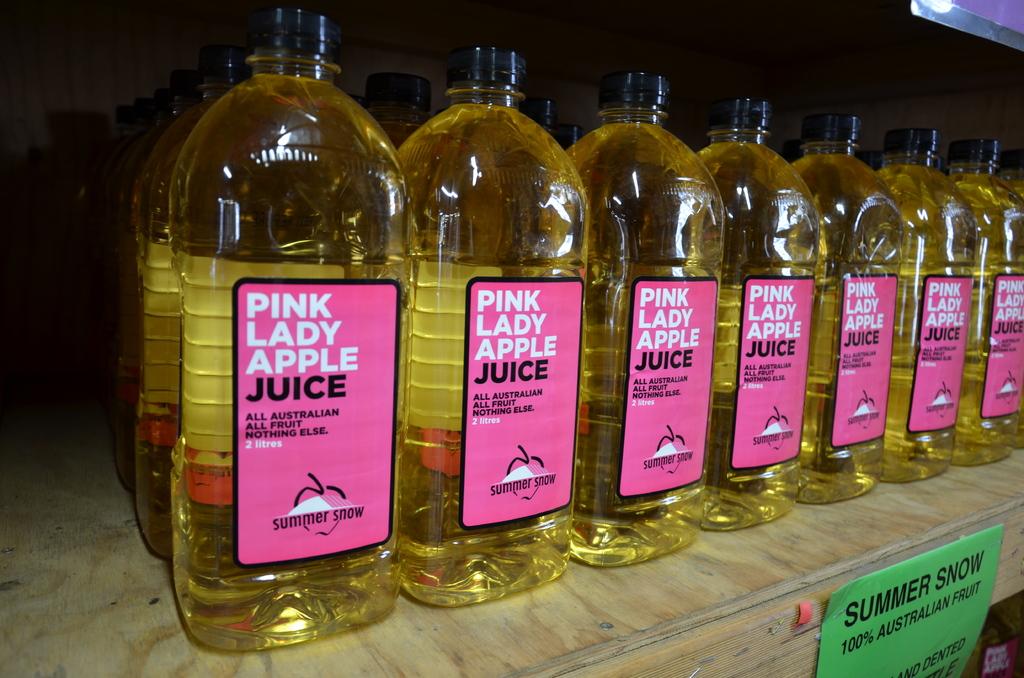What type of drink is this?
Offer a very short reply. Apple juice. 